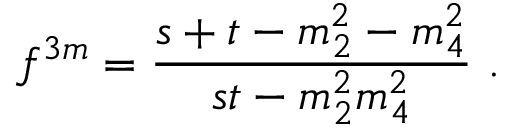<formula> <loc_0><loc_0><loc_500><loc_500>f ^ { 3 m } = \frac { s + t - m _ { 2 } ^ { 2 } - m _ { 4 } ^ { 2 } } { s t - m _ { 2 } ^ { 2 } m _ { 4 } ^ { 2 } } .</formula> 